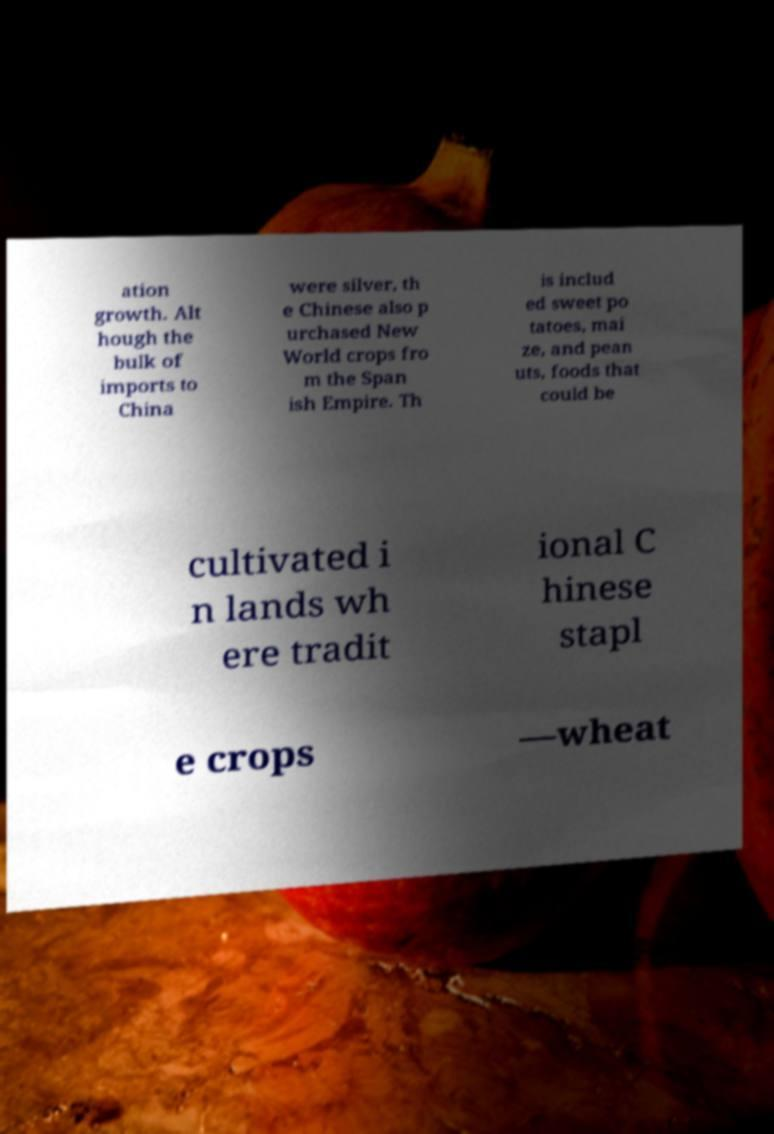Could you extract and type out the text from this image? ation growth. Alt hough the bulk of imports to China were silver, th e Chinese also p urchased New World crops fro m the Span ish Empire. Th is includ ed sweet po tatoes, mai ze, and pean uts, foods that could be cultivated i n lands wh ere tradit ional C hinese stapl e crops —wheat 